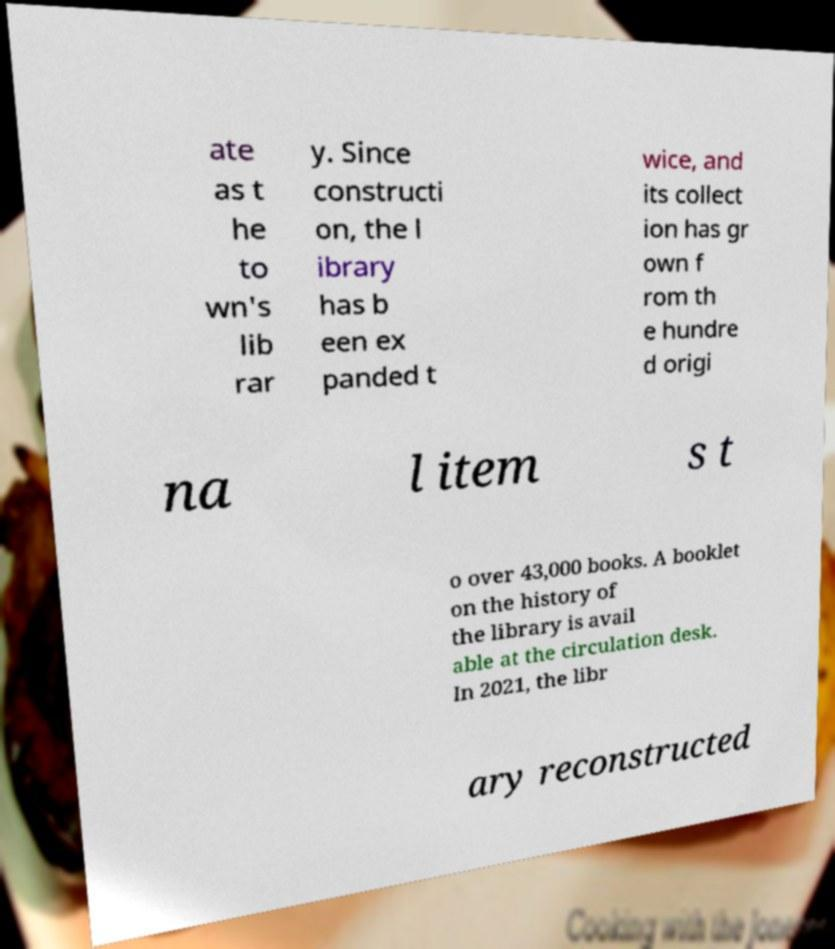Can you read and provide the text displayed in the image?This photo seems to have some interesting text. Can you extract and type it out for me? ate as t he to wn's lib rar y. Since constructi on, the l ibrary has b een ex panded t wice, and its collect ion has gr own f rom th e hundre d origi na l item s t o over 43,000 books. A booklet on the history of the library is avail able at the circulation desk. In 2021, the libr ary reconstructed 